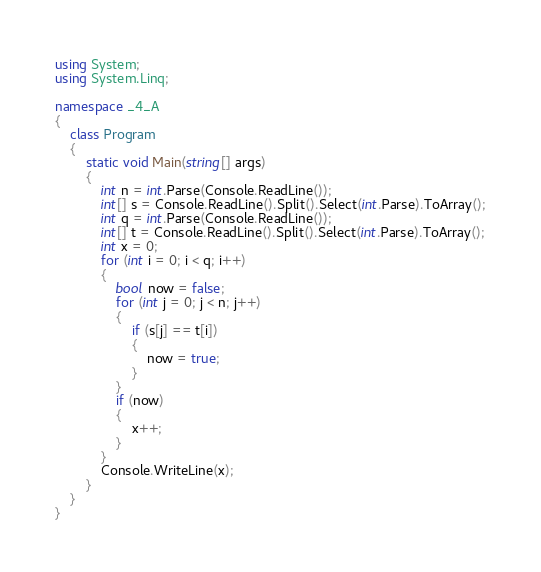<code> <loc_0><loc_0><loc_500><loc_500><_C#_>using System;
using System.Linq;

namespace _4_A
{
    class Program
    {
        static void Main(string[] args)
        {
            int n = int.Parse(Console.ReadLine());
            int[] s = Console.ReadLine().Split().Select(int.Parse).ToArray();
            int q = int.Parse(Console.ReadLine());
            int[] t = Console.ReadLine().Split().Select(int.Parse).ToArray();
            int x = 0;
            for (int i = 0; i < q; i++)
            {
                bool now = false;
                for (int j = 0; j < n; j++)
                {
                    if (s[j] == t[i])
                    {
                        now = true;
                    }
                }
                if (now)
                {
                    x++;
                }
            }
            Console.WriteLine(x);
        }
    }
}</code> 